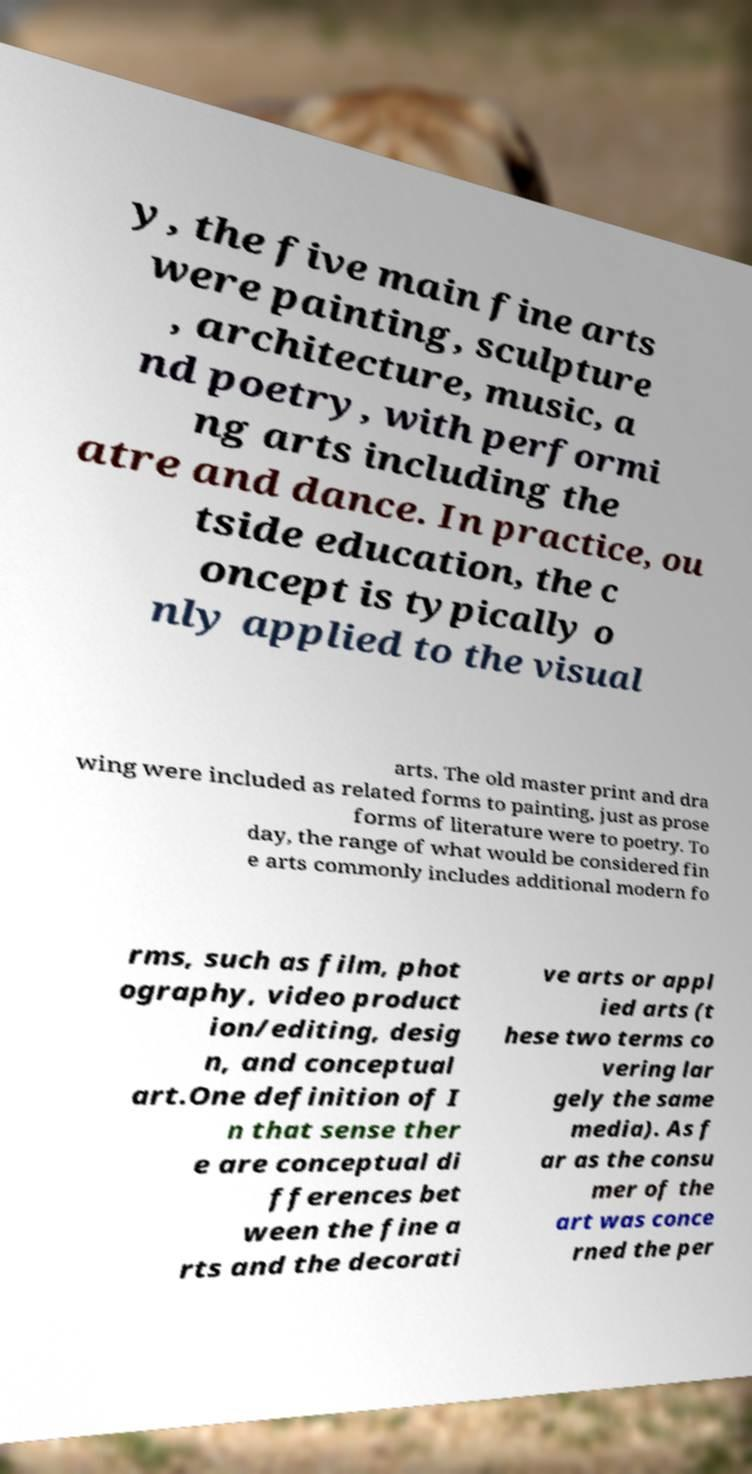I need the written content from this picture converted into text. Can you do that? y, the five main fine arts were painting, sculpture , architecture, music, a nd poetry, with performi ng arts including the atre and dance. In practice, ou tside education, the c oncept is typically o nly applied to the visual arts. The old master print and dra wing were included as related forms to painting, just as prose forms of literature were to poetry. To day, the range of what would be considered fin e arts commonly includes additional modern fo rms, such as film, phot ography, video product ion/editing, desig n, and conceptual art.One definition of I n that sense ther e are conceptual di fferences bet ween the fine a rts and the decorati ve arts or appl ied arts (t hese two terms co vering lar gely the same media). As f ar as the consu mer of the art was conce rned the per 